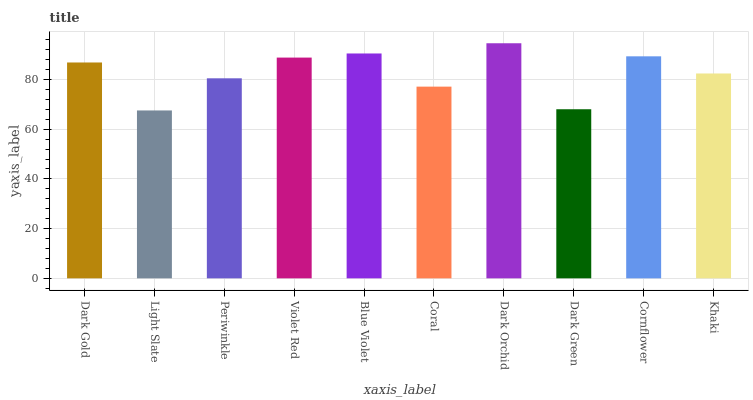Is Periwinkle the minimum?
Answer yes or no. No. Is Periwinkle the maximum?
Answer yes or no. No. Is Periwinkle greater than Light Slate?
Answer yes or no. Yes. Is Light Slate less than Periwinkle?
Answer yes or no. Yes. Is Light Slate greater than Periwinkle?
Answer yes or no. No. Is Periwinkle less than Light Slate?
Answer yes or no. No. Is Dark Gold the high median?
Answer yes or no. Yes. Is Khaki the low median?
Answer yes or no. Yes. Is Cornflower the high median?
Answer yes or no. No. Is Coral the low median?
Answer yes or no. No. 